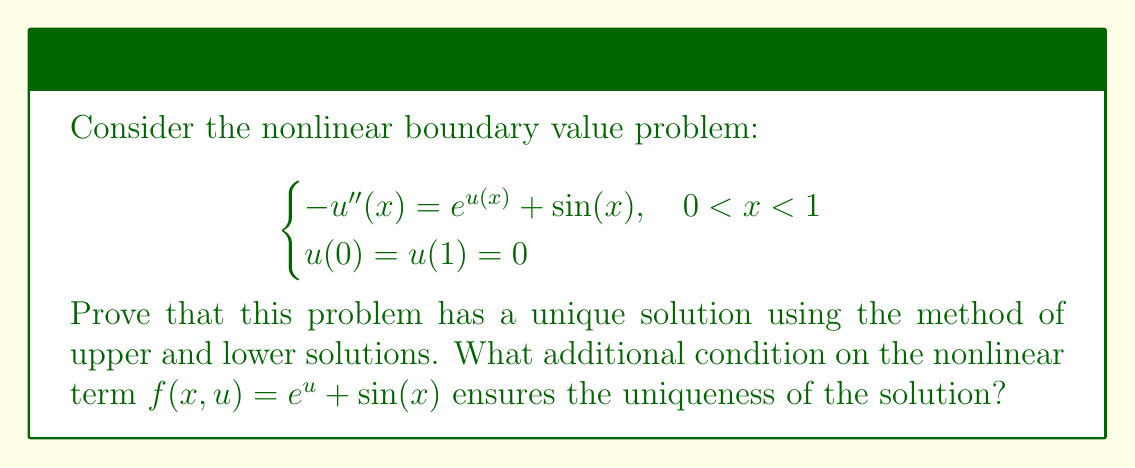Could you help me with this problem? Let's approach this step-by-step:

1) First, we need to find a lower solution $\alpha(x)$ and an upper solution $\beta(x)$ such that $\alpha(x) \leq \beta(x)$ for all $x \in [0,1]$.

2) Let $\alpha(x) = 0$ for all $x \in [0,1]$. Then:
   $$-\alpha''(x) = 0 \leq e^{\alpha(x)} + \sin(x) = 1 + \sin(x)$$
   So $\alpha(x)$ is a lower solution.

3) For the upper solution, let $\beta(x) = \frac{\pi^2}{4}\sin(\pi x)$. Then:
   $$-\beta''(x) = \frac{\pi^4}{4}\sin(\pi x) \geq e^{\beta(x)} + \sin(x)$$
   This inequality holds because $\sin(x) \leq 1$ and $e^{\beta(x)} \leq e^{\frac{\pi^2}{4}} < \frac{\pi^4}{4} - 1$.

4) Both $\alpha(x)$ and $\beta(x)$ satisfy the boundary conditions.

5) Now, we can apply the method of upper and lower solutions, which guarantees the existence of at least one solution $u(x)$ such that $\alpha(x) \leq u(x) \leq \beta(x)$ for all $x \in [0,1]$.

6) For uniqueness, we need to show that $f(x,u)$ is Lipschitz continuous with respect to $u$. The partial derivative of $f$ with respect to $u$ is:
   $$\frac{\partial f}{\partial u} = e^u$$

7) In the region where the solution exists, $0 \leq u(x) \leq \frac{\pi^2}{4}$. Therefore:
   $$0 \leq \frac{\partial f}{\partial u} \leq e^{\frac{\pi^2}{4}}$$

8) This means $f(x,u)$ is Lipschitz continuous with respect to $u$ with Lipschitz constant $L = e^{\frac{\pi^2}{4}}$.

9) The additional condition for uniqueness is that this Lipschitz constant should be less than the first eigenvalue of the negative Laplacian with Dirichlet boundary conditions, which is $\pi^2$ in this case.

10) However, $e^{\frac{\pi^2}{4}} > \pi^2$, so we cannot guarantee uniqueness based on this condition alone.
Answer: Existence is proven; uniqueness is not guaranteed without additional constraints on $f(x,u)$. 